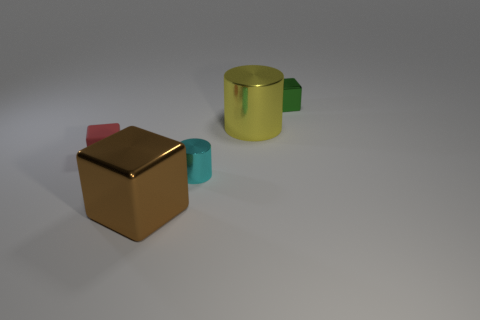Does the metallic object that is in front of the cyan shiny cylinder have the same shape as the green object?
Offer a very short reply. Yes. There is a big shiny thing behind the small cyan metallic cylinder that is right of the small block that is on the left side of the tiny green block; what shape is it?
Your response must be concise. Cylinder. What material is the object that is to the left of the cyan thing and in front of the rubber thing?
Provide a succinct answer. Metal. Are there fewer small cubes than purple metal things?
Your response must be concise. No. Is the shape of the cyan shiny object the same as the green metal thing behind the large brown object?
Provide a short and direct response. No. There is a cylinder in front of the yellow thing; is it the same size as the green metal thing?
Your response must be concise. Yes. There is a yellow thing that is the same size as the brown metal object; what shape is it?
Offer a very short reply. Cylinder. Does the tiny matte thing have the same shape as the brown thing?
Offer a terse response. Yes. How many big yellow objects have the same shape as the green shiny object?
Keep it short and to the point. 0. What number of small cyan things are behind the tiny green metallic cube?
Offer a very short reply. 0. 